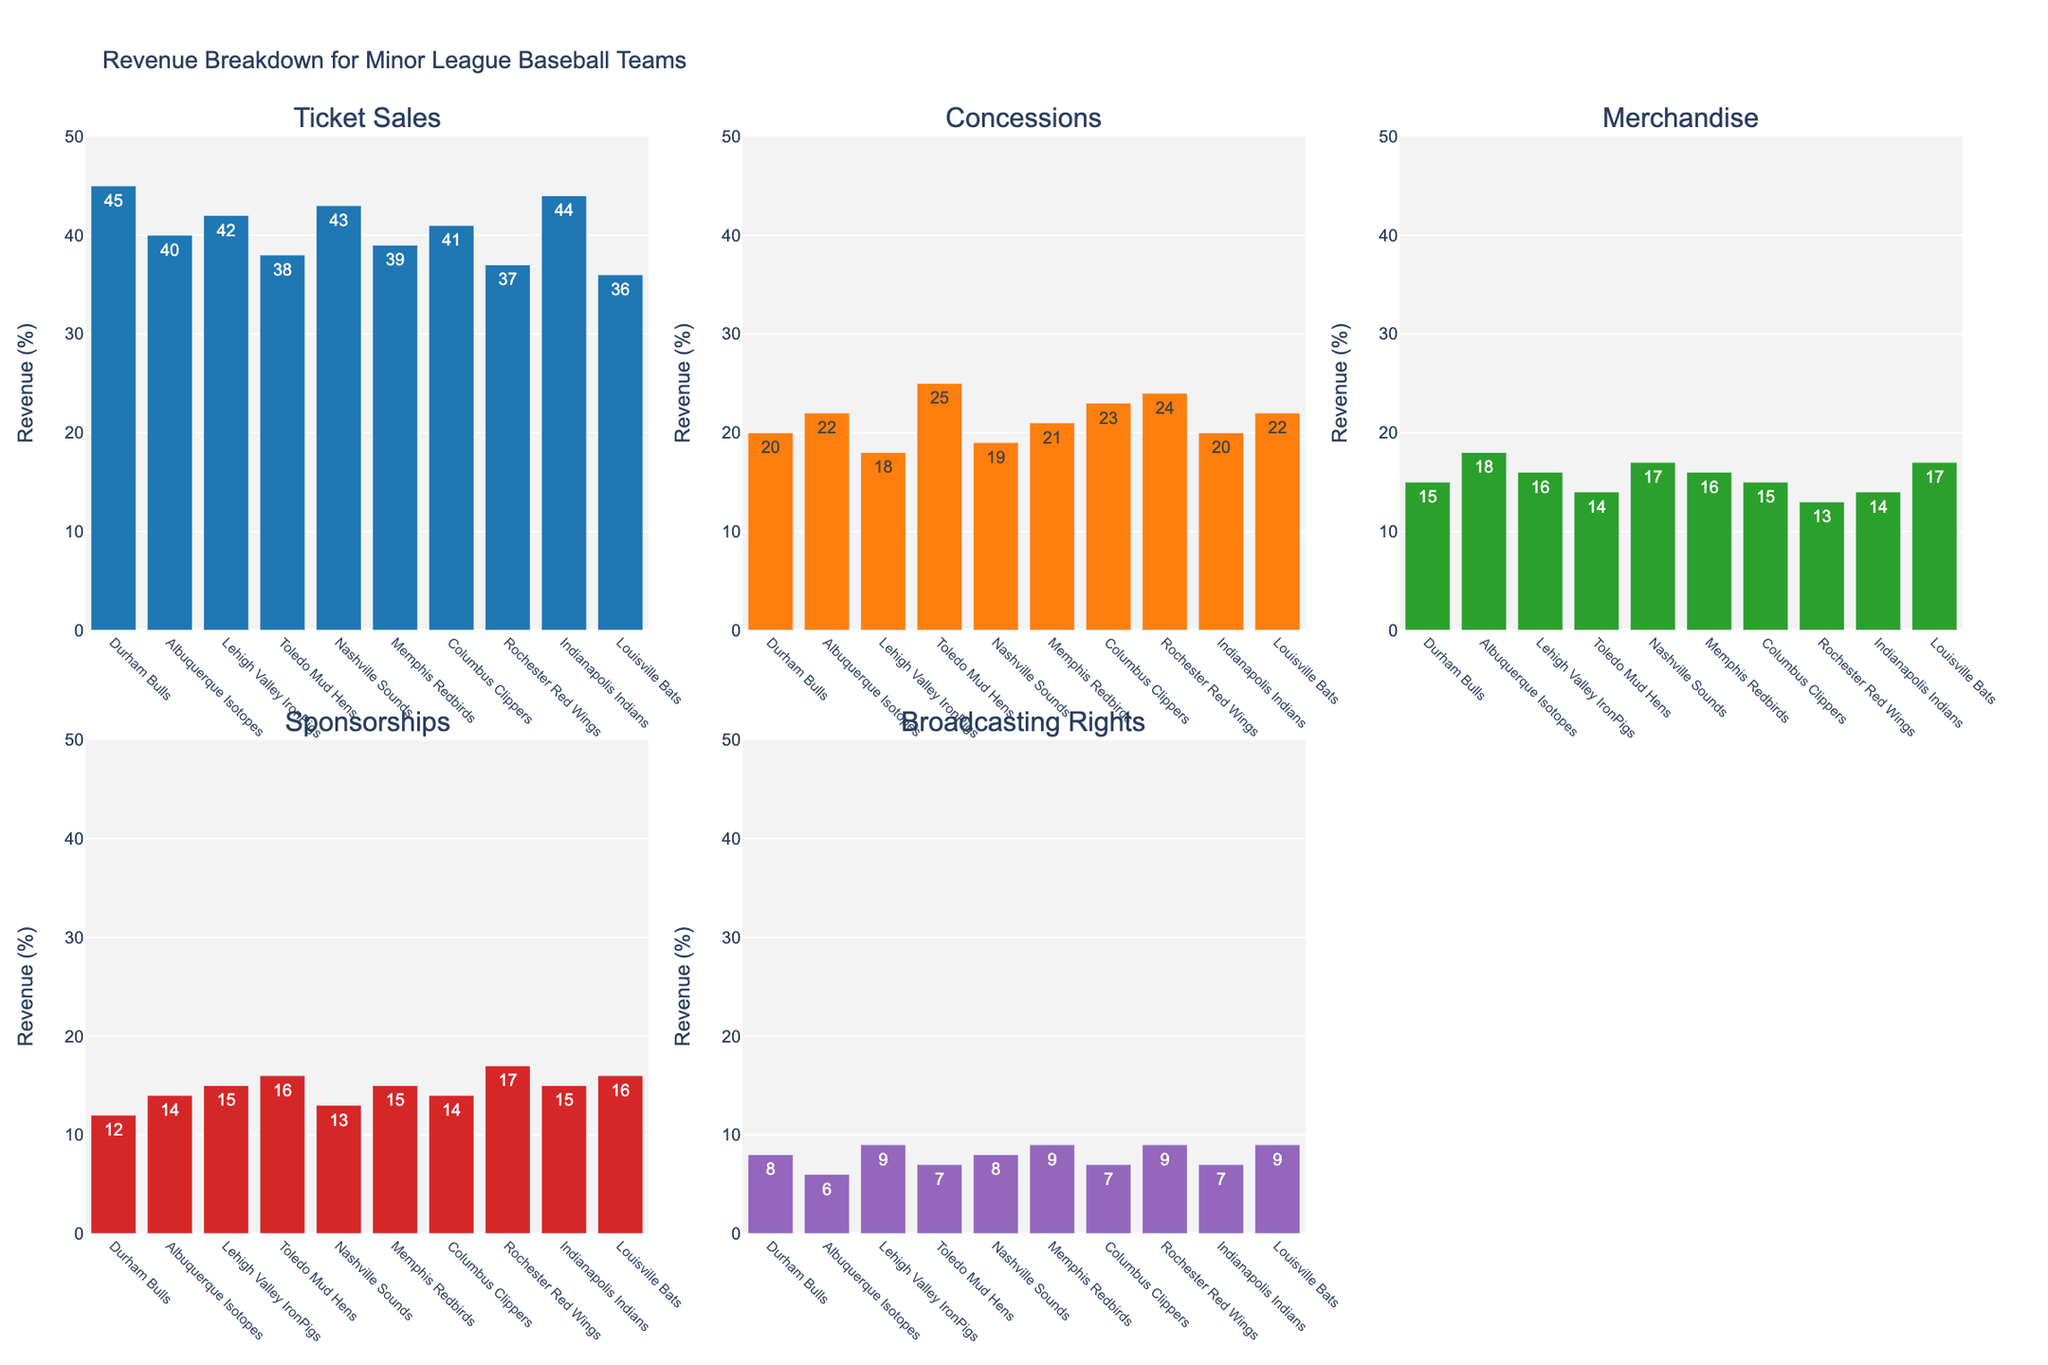What is the title of the figure? The title is located at the top of the figure and it is usually descriptive of the content. In this case, the title is clearly shown at the top of the image.
Answer: Revenue Breakdown for Minor League Baseball Teams How many revenue sources are displayed in the figure? By observing the subplot titles, we can see each title corresponds to a different revenue source column from the data. Counting these titles gives us the answer.
Answer: 5 Which team has the highest percentage of revenue from ticket sales? By examining the bar chart for 'Ticket Sales', we compare the heights of all bars. The tallest bar represents the team with the highest percentage.
Answer: Durham Bulls What is the approximate range for the y-axis across all subplots? The y-axis on all subplots is consistent, so we look at the tick marks and grid lines to determine the minimum and maximum values.
Answer: 0 to 50 Which team has the lowest percentage of revenue from broadcasting rights? Within the 'Broadcasting Rights' subplot, look for the shortest bar. This bar corresponds to the team with the lowest percentage in this category.
Answer: Albuquerque Isotopes What is the average percentage of revenue from merchandise for the Nashville Sounds and Memphis Redbirds? Identify the bars in the 'Merchandise' subplot for both teams. Add their percentages and divide by 2 to find the average.
Answer: (17 + 16) / 2 = 16.5 Is there a team that has the same percentage for concessions and merchandise? Check each team's bars within the 'Concessions' and 'Merchandise' subplots to see if any pair has equal values.
Answer: No Which two teams have the closest revenue percentages for sponsorships and what are these percentages? Compare the 'Sponsorships' bars for all teams and find the two with the smallest difference in height.
Answer: Lehigh Valley IronPigs and Louisville Bats; both have 15% By how much do ticket sales for the Rochester Red Wings exceed those of the Toledo Mud Hens? Find the percentage for both teams in the 'Ticket Sales' subplot and calculate the difference.
Answer: 37 - 38 = -1 (Toledo Mud Hens exceed by 1) Which team shows the highest total revenue percentage combining all sources? Sum the percentages across all subplots for each team and identify the maximum total.
Answer: Lehigh Valley IronPigs 